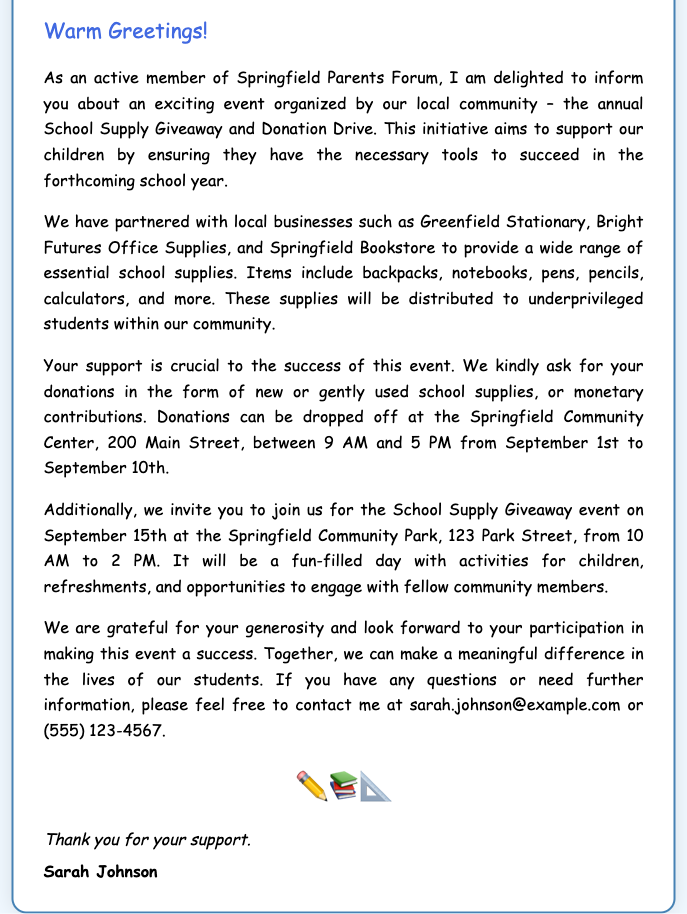What is the name of the organizer? The name of the organizer, as stated in the document, is Sarah Johnson.
Answer: Sarah Johnson Where will donations be accepted? Donations can be dropped off at the Springfield Community Center, as mentioned in the document.
Answer: Springfield Community Center What date is the School Supply Giveaway event? The School Supply Giveaway event is scheduled for September 15th, according to the invitation.
Answer: September 15th What types of supplies can be donated? The document lists school supplies such as backpacks, notebooks, and pens as donation items.
Answer: Backpacks, notebooks, and pens What is the time for the donation drop-off? The donation drop-off hours are from 9 AM to 5 PM, as indicated in the document.
Answer: 9 AM to 5 PM Which businesses are partnered for supplies? The partnered businesses mentioned in the document include Greenfield Stationary and Springfield Bookstore.
Answer: Greenfield Stationary, Springfield Bookstore What is the location of the School Supply Giveaway event? The location for the event is the Springfield Community Park, as stated in the invitation.
Answer: Springfield Community Park How can someone contact Sarah Johnson? The contact details for Sarah Johnson are provided in the document, including an email address and phone number.
Answer: sarah.johnson@example.com or (555) 123-4567 